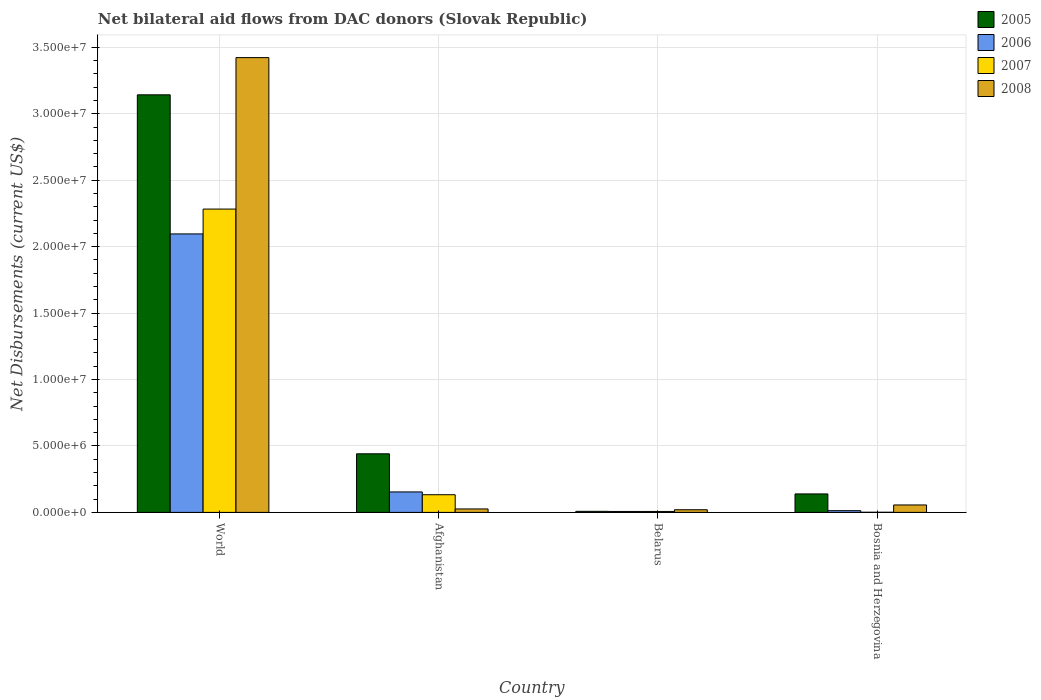How many different coloured bars are there?
Make the answer very short. 4. Are the number of bars per tick equal to the number of legend labels?
Give a very brief answer. Yes. How many bars are there on the 2nd tick from the left?
Your answer should be compact. 4. How many bars are there on the 4th tick from the right?
Your answer should be compact. 4. What is the label of the 3rd group of bars from the left?
Provide a short and direct response. Belarus. What is the net bilateral aid flows in 2008 in World?
Offer a terse response. 3.42e+07. Across all countries, what is the maximum net bilateral aid flows in 2007?
Your response must be concise. 2.28e+07. Across all countries, what is the minimum net bilateral aid flows in 2006?
Offer a terse response. 7.00e+04. In which country was the net bilateral aid flows in 2008 minimum?
Your answer should be compact. Belarus. What is the total net bilateral aid flows in 2008 in the graph?
Provide a succinct answer. 3.52e+07. What is the difference between the net bilateral aid flows in 2006 in Afghanistan and that in World?
Offer a very short reply. -1.94e+07. What is the difference between the net bilateral aid flows in 2008 in Bosnia and Herzegovina and the net bilateral aid flows in 2005 in World?
Ensure brevity in your answer.  -3.09e+07. What is the average net bilateral aid flows in 2006 per country?
Provide a short and direct response. 5.68e+06. What is the difference between the net bilateral aid flows of/in 2007 and net bilateral aid flows of/in 2008 in Bosnia and Herzegovina?
Offer a terse response. -5.50e+05. Is the difference between the net bilateral aid flows in 2007 in Afghanistan and World greater than the difference between the net bilateral aid flows in 2008 in Afghanistan and World?
Ensure brevity in your answer.  Yes. What is the difference between the highest and the second highest net bilateral aid flows in 2005?
Ensure brevity in your answer.  2.70e+07. What is the difference between the highest and the lowest net bilateral aid flows in 2007?
Your response must be concise. 2.28e+07. What does the 3rd bar from the left in World represents?
Give a very brief answer. 2007. Is it the case that in every country, the sum of the net bilateral aid flows in 2006 and net bilateral aid flows in 2008 is greater than the net bilateral aid flows in 2007?
Give a very brief answer. Yes. How many bars are there?
Provide a succinct answer. 16. What is the difference between two consecutive major ticks on the Y-axis?
Keep it short and to the point. 5.00e+06. How are the legend labels stacked?
Give a very brief answer. Vertical. What is the title of the graph?
Give a very brief answer. Net bilateral aid flows from DAC donors (Slovak Republic). What is the label or title of the X-axis?
Ensure brevity in your answer.  Country. What is the label or title of the Y-axis?
Keep it short and to the point. Net Disbursements (current US$). What is the Net Disbursements (current US$) in 2005 in World?
Keep it short and to the point. 3.14e+07. What is the Net Disbursements (current US$) in 2006 in World?
Offer a terse response. 2.10e+07. What is the Net Disbursements (current US$) of 2007 in World?
Your response must be concise. 2.28e+07. What is the Net Disbursements (current US$) of 2008 in World?
Provide a short and direct response. 3.42e+07. What is the Net Disbursements (current US$) of 2005 in Afghanistan?
Keep it short and to the point. 4.41e+06. What is the Net Disbursements (current US$) in 2006 in Afghanistan?
Provide a succinct answer. 1.54e+06. What is the Net Disbursements (current US$) in 2007 in Afghanistan?
Your answer should be very brief. 1.33e+06. What is the Net Disbursements (current US$) in 2008 in Afghanistan?
Your response must be concise. 2.60e+05. What is the Net Disbursements (current US$) in 2006 in Belarus?
Keep it short and to the point. 7.00e+04. What is the Net Disbursements (current US$) in 2007 in Belarus?
Give a very brief answer. 7.00e+04. What is the Net Disbursements (current US$) in 2005 in Bosnia and Herzegovina?
Offer a terse response. 1.39e+06. What is the Net Disbursements (current US$) of 2006 in Bosnia and Herzegovina?
Make the answer very short. 1.30e+05. What is the Net Disbursements (current US$) in 2007 in Bosnia and Herzegovina?
Your answer should be very brief. 10000. What is the Net Disbursements (current US$) in 2008 in Bosnia and Herzegovina?
Provide a short and direct response. 5.60e+05. Across all countries, what is the maximum Net Disbursements (current US$) of 2005?
Your answer should be very brief. 3.14e+07. Across all countries, what is the maximum Net Disbursements (current US$) in 2006?
Your answer should be compact. 2.10e+07. Across all countries, what is the maximum Net Disbursements (current US$) of 2007?
Make the answer very short. 2.28e+07. Across all countries, what is the maximum Net Disbursements (current US$) of 2008?
Provide a succinct answer. 3.42e+07. Across all countries, what is the minimum Net Disbursements (current US$) in 2007?
Offer a very short reply. 10000. What is the total Net Disbursements (current US$) of 2005 in the graph?
Give a very brief answer. 3.73e+07. What is the total Net Disbursements (current US$) of 2006 in the graph?
Give a very brief answer. 2.27e+07. What is the total Net Disbursements (current US$) of 2007 in the graph?
Provide a succinct answer. 2.42e+07. What is the total Net Disbursements (current US$) of 2008 in the graph?
Offer a very short reply. 3.52e+07. What is the difference between the Net Disbursements (current US$) of 2005 in World and that in Afghanistan?
Provide a succinct answer. 2.70e+07. What is the difference between the Net Disbursements (current US$) of 2006 in World and that in Afghanistan?
Your answer should be very brief. 1.94e+07. What is the difference between the Net Disbursements (current US$) in 2007 in World and that in Afghanistan?
Your answer should be very brief. 2.15e+07. What is the difference between the Net Disbursements (current US$) in 2008 in World and that in Afghanistan?
Ensure brevity in your answer.  3.40e+07. What is the difference between the Net Disbursements (current US$) in 2005 in World and that in Belarus?
Ensure brevity in your answer.  3.14e+07. What is the difference between the Net Disbursements (current US$) in 2006 in World and that in Belarus?
Offer a very short reply. 2.09e+07. What is the difference between the Net Disbursements (current US$) of 2007 in World and that in Belarus?
Offer a very short reply. 2.28e+07. What is the difference between the Net Disbursements (current US$) in 2008 in World and that in Belarus?
Make the answer very short. 3.40e+07. What is the difference between the Net Disbursements (current US$) in 2005 in World and that in Bosnia and Herzegovina?
Your response must be concise. 3.00e+07. What is the difference between the Net Disbursements (current US$) of 2006 in World and that in Bosnia and Herzegovina?
Your answer should be compact. 2.08e+07. What is the difference between the Net Disbursements (current US$) of 2007 in World and that in Bosnia and Herzegovina?
Make the answer very short. 2.28e+07. What is the difference between the Net Disbursements (current US$) of 2008 in World and that in Bosnia and Herzegovina?
Your answer should be very brief. 3.37e+07. What is the difference between the Net Disbursements (current US$) of 2005 in Afghanistan and that in Belarus?
Give a very brief answer. 4.33e+06. What is the difference between the Net Disbursements (current US$) of 2006 in Afghanistan and that in Belarus?
Your response must be concise. 1.47e+06. What is the difference between the Net Disbursements (current US$) of 2007 in Afghanistan and that in Belarus?
Your answer should be very brief. 1.26e+06. What is the difference between the Net Disbursements (current US$) of 2008 in Afghanistan and that in Belarus?
Your answer should be very brief. 6.00e+04. What is the difference between the Net Disbursements (current US$) of 2005 in Afghanistan and that in Bosnia and Herzegovina?
Give a very brief answer. 3.02e+06. What is the difference between the Net Disbursements (current US$) of 2006 in Afghanistan and that in Bosnia and Herzegovina?
Offer a terse response. 1.41e+06. What is the difference between the Net Disbursements (current US$) in 2007 in Afghanistan and that in Bosnia and Herzegovina?
Provide a succinct answer. 1.32e+06. What is the difference between the Net Disbursements (current US$) of 2008 in Afghanistan and that in Bosnia and Herzegovina?
Offer a very short reply. -3.00e+05. What is the difference between the Net Disbursements (current US$) in 2005 in Belarus and that in Bosnia and Herzegovina?
Your response must be concise. -1.31e+06. What is the difference between the Net Disbursements (current US$) of 2006 in Belarus and that in Bosnia and Herzegovina?
Offer a terse response. -6.00e+04. What is the difference between the Net Disbursements (current US$) of 2008 in Belarus and that in Bosnia and Herzegovina?
Your response must be concise. -3.60e+05. What is the difference between the Net Disbursements (current US$) of 2005 in World and the Net Disbursements (current US$) of 2006 in Afghanistan?
Give a very brief answer. 2.99e+07. What is the difference between the Net Disbursements (current US$) in 2005 in World and the Net Disbursements (current US$) in 2007 in Afghanistan?
Ensure brevity in your answer.  3.01e+07. What is the difference between the Net Disbursements (current US$) of 2005 in World and the Net Disbursements (current US$) of 2008 in Afghanistan?
Ensure brevity in your answer.  3.12e+07. What is the difference between the Net Disbursements (current US$) of 2006 in World and the Net Disbursements (current US$) of 2007 in Afghanistan?
Give a very brief answer. 1.96e+07. What is the difference between the Net Disbursements (current US$) in 2006 in World and the Net Disbursements (current US$) in 2008 in Afghanistan?
Provide a succinct answer. 2.07e+07. What is the difference between the Net Disbursements (current US$) of 2007 in World and the Net Disbursements (current US$) of 2008 in Afghanistan?
Your answer should be compact. 2.26e+07. What is the difference between the Net Disbursements (current US$) of 2005 in World and the Net Disbursements (current US$) of 2006 in Belarus?
Your answer should be compact. 3.14e+07. What is the difference between the Net Disbursements (current US$) in 2005 in World and the Net Disbursements (current US$) in 2007 in Belarus?
Provide a short and direct response. 3.14e+07. What is the difference between the Net Disbursements (current US$) in 2005 in World and the Net Disbursements (current US$) in 2008 in Belarus?
Ensure brevity in your answer.  3.12e+07. What is the difference between the Net Disbursements (current US$) of 2006 in World and the Net Disbursements (current US$) of 2007 in Belarus?
Your answer should be compact. 2.09e+07. What is the difference between the Net Disbursements (current US$) in 2006 in World and the Net Disbursements (current US$) in 2008 in Belarus?
Your response must be concise. 2.08e+07. What is the difference between the Net Disbursements (current US$) of 2007 in World and the Net Disbursements (current US$) of 2008 in Belarus?
Offer a very short reply. 2.26e+07. What is the difference between the Net Disbursements (current US$) in 2005 in World and the Net Disbursements (current US$) in 2006 in Bosnia and Herzegovina?
Give a very brief answer. 3.13e+07. What is the difference between the Net Disbursements (current US$) of 2005 in World and the Net Disbursements (current US$) of 2007 in Bosnia and Herzegovina?
Ensure brevity in your answer.  3.14e+07. What is the difference between the Net Disbursements (current US$) of 2005 in World and the Net Disbursements (current US$) of 2008 in Bosnia and Herzegovina?
Offer a very short reply. 3.09e+07. What is the difference between the Net Disbursements (current US$) of 2006 in World and the Net Disbursements (current US$) of 2007 in Bosnia and Herzegovina?
Provide a short and direct response. 2.10e+07. What is the difference between the Net Disbursements (current US$) of 2006 in World and the Net Disbursements (current US$) of 2008 in Bosnia and Herzegovina?
Provide a short and direct response. 2.04e+07. What is the difference between the Net Disbursements (current US$) in 2007 in World and the Net Disbursements (current US$) in 2008 in Bosnia and Herzegovina?
Give a very brief answer. 2.23e+07. What is the difference between the Net Disbursements (current US$) in 2005 in Afghanistan and the Net Disbursements (current US$) in 2006 in Belarus?
Provide a succinct answer. 4.34e+06. What is the difference between the Net Disbursements (current US$) of 2005 in Afghanistan and the Net Disbursements (current US$) of 2007 in Belarus?
Provide a succinct answer. 4.34e+06. What is the difference between the Net Disbursements (current US$) of 2005 in Afghanistan and the Net Disbursements (current US$) of 2008 in Belarus?
Offer a terse response. 4.21e+06. What is the difference between the Net Disbursements (current US$) in 2006 in Afghanistan and the Net Disbursements (current US$) in 2007 in Belarus?
Provide a succinct answer. 1.47e+06. What is the difference between the Net Disbursements (current US$) of 2006 in Afghanistan and the Net Disbursements (current US$) of 2008 in Belarus?
Ensure brevity in your answer.  1.34e+06. What is the difference between the Net Disbursements (current US$) of 2007 in Afghanistan and the Net Disbursements (current US$) of 2008 in Belarus?
Offer a very short reply. 1.13e+06. What is the difference between the Net Disbursements (current US$) of 2005 in Afghanistan and the Net Disbursements (current US$) of 2006 in Bosnia and Herzegovina?
Your answer should be compact. 4.28e+06. What is the difference between the Net Disbursements (current US$) of 2005 in Afghanistan and the Net Disbursements (current US$) of 2007 in Bosnia and Herzegovina?
Offer a terse response. 4.40e+06. What is the difference between the Net Disbursements (current US$) of 2005 in Afghanistan and the Net Disbursements (current US$) of 2008 in Bosnia and Herzegovina?
Make the answer very short. 3.85e+06. What is the difference between the Net Disbursements (current US$) of 2006 in Afghanistan and the Net Disbursements (current US$) of 2007 in Bosnia and Herzegovina?
Your response must be concise. 1.53e+06. What is the difference between the Net Disbursements (current US$) in 2006 in Afghanistan and the Net Disbursements (current US$) in 2008 in Bosnia and Herzegovina?
Offer a terse response. 9.80e+05. What is the difference between the Net Disbursements (current US$) in 2007 in Afghanistan and the Net Disbursements (current US$) in 2008 in Bosnia and Herzegovina?
Ensure brevity in your answer.  7.70e+05. What is the difference between the Net Disbursements (current US$) of 2005 in Belarus and the Net Disbursements (current US$) of 2007 in Bosnia and Herzegovina?
Your answer should be very brief. 7.00e+04. What is the difference between the Net Disbursements (current US$) of 2005 in Belarus and the Net Disbursements (current US$) of 2008 in Bosnia and Herzegovina?
Provide a succinct answer. -4.80e+05. What is the difference between the Net Disbursements (current US$) of 2006 in Belarus and the Net Disbursements (current US$) of 2008 in Bosnia and Herzegovina?
Ensure brevity in your answer.  -4.90e+05. What is the difference between the Net Disbursements (current US$) in 2007 in Belarus and the Net Disbursements (current US$) in 2008 in Bosnia and Herzegovina?
Keep it short and to the point. -4.90e+05. What is the average Net Disbursements (current US$) of 2005 per country?
Provide a succinct answer. 9.33e+06. What is the average Net Disbursements (current US$) in 2006 per country?
Give a very brief answer. 5.68e+06. What is the average Net Disbursements (current US$) in 2007 per country?
Ensure brevity in your answer.  6.06e+06. What is the average Net Disbursements (current US$) of 2008 per country?
Offer a terse response. 8.81e+06. What is the difference between the Net Disbursements (current US$) of 2005 and Net Disbursements (current US$) of 2006 in World?
Provide a succinct answer. 1.05e+07. What is the difference between the Net Disbursements (current US$) in 2005 and Net Disbursements (current US$) in 2007 in World?
Make the answer very short. 8.60e+06. What is the difference between the Net Disbursements (current US$) of 2005 and Net Disbursements (current US$) of 2008 in World?
Your answer should be compact. -2.80e+06. What is the difference between the Net Disbursements (current US$) in 2006 and Net Disbursements (current US$) in 2007 in World?
Offer a very short reply. -1.87e+06. What is the difference between the Net Disbursements (current US$) of 2006 and Net Disbursements (current US$) of 2008 in World?
Ensure brevity in your answer.  -1.33e+07. What is the difference between the Net Disbursements (current US$) of 2007 and Net Disbursements (current US$) of 2008 in World?
Your answer should be very brief. -1.14e+07. What is the difference between the Net Disbursements (current US$) in 2005 and Net Disbursements (current US$) in 2006 in Afghanistan?
Provide a short and direct response. 2.87e+06. What is the difference between the Net Disbursements (current US$) in 2005 and Net Disbursements (current US$) in 2007 in Afghanistan?
Keep it short and to the point. 3.08e+06. What is the difference between the Net Disbursements (current US$) in 2005 and Net Disbursements (current US$) in 2008 in Afghanistan?
Your answer should be very brief. 4.15e+06. What is the difference between the Net Disbursements (current US$) of 2006 and Net Disbursements (current US$) of 2007 in Afghanistan?
Offer a very short reply. 2.10e+05. What is the difference between the Net Disbursements (current US$) in 2006 and Net Disbursements (current US$) in 2008 in Afghanistan?
Offer a very short reply. 1.28e+06. What is the difference between the Net Disbursements (current US$) in 2007 and Net Disbursements (current US$) in 2008 in Afghanistan?
Make the answer very short. 1.07e+06. What is the difference between the Net Disbursements (current US$) of 2005 and Net Disbursements (current US$) of 2007 in Belarus?
Your response must be concise. 10000. What is the difference between the Net Disbursements (current US$) of 2006 and Net Disbursements (current US$) of 2007 in Belarus?
Provide a short and direct response. 0. What is the difference between the Net Disbursements (current US$) in 2006 and Net Disbursements (current US$) in 2008 in Belarus?
Provide a succinct answer. -1.30e+05. What is the difference between the Net Disbursements (current US$) in 2005 and Net Disbursements (current US$) in 2006 in Bosnia and Herzegovina?
Offer a very short reply. 1.26e+06. What is the difference between the Net Disbursements (current US$) of 2005 and Net Disbursements (current US$) of 2007 in Bosnia and Herzegovina?
Your answer should be very brief. 1.38e+06. What is the difference between the Net Disbursements (current US$) of 2005 and Net Disbursements (current US$) of 2008 in Bosnia and Herzegovina?
Ensure brevity in your answer.  8.30e+05. What is the difference between the Net Disbursements (current US$) in 2006 and Net Disbursements (current US$) in 2007 in Bosnia and Herzegovina?
Make the answer very short. 1.20e+05. What is the difference between the Net Disbursements (current US$) in 2006 and Net Disbursements (current US$) in 2008 in Bosnia and Herzegovina?
Your answer should be very brief. -4.30e+05. What is the difference between the Net Disbursements (current US$) in 2007 and Net Disbursements (current US$) in 2008 in Bosnia and Herzegovina?
Provide a short and direct response. -5.50e+05. What is the ratio of the Net Disbursements (current US$) in 2005 in World to that in Afghanistan?
Offer a terse response. 7.13. What is the ratio of the Net Disbursements (current US$) of 2006 in World to that in Afghanistan?
Your response must be concise. 13.61. What is the ratio of the Net Disbursements (current US$) of 2007 in World to that in Afghanistan?
Offer a terse response. 17.17. What is the ratio of the Net Disbursements (current US$) in 2008 in World to that in Afghanistan?
Your answer should be compact. 131.65. What is the ratio of the Net Disbursements (current US$) of 2005 in World to that in Belarus?
Your response must be concise. 392.88. What is the ratio of the Net Disbursements (current US$) in 2006 in World to that in Belarus?
Offer a terse response. 299.43. What is the ratio of the Net Disbursements (current US$) in 2007 in World to that in Belarus?
Offer a very short reply. 326.14. What is the ratio of the Net Disbursements (current US$) of 2008 in World to that in Belarus?
Keep it short and to the point. 171.15. What is the ratio of the Net Disbursements (current US$) of 2005 in World to that in Bosnia and Herzegovina?
Your response must be concise. 22.61. What is the ratio of the Net Disbursements (current US$) in 2006 in World to that in Bosnia and Herzegovina?
Your answer should be very brief. 161.23. What is the ratio of the Net Disbursements (current US$) of 2007 in World to that in Bosnia and Herzegovina?
Provide a short and direct response. 2283. What is the ratio of the Net Disbursements (current US$) of 2008 in World to that in Bosnia and Herzegovina?
Offer a very short reply. 61.12. What is the ratio of the Net Disbursements (current US$) of 2005 in Afghanistan to that in Belarus?
Offer a very short reply. 55.12. What is the ratio of the Net Disbursements (current US$) in 2006 in Afghanistan to that in Belarus?
Keep it short and to the point. 22. What is the ratio of the Net Disbursements (current US$) in 2007 in Afghanistan to that in Belarus?
Ensure brevity in your answer.  19. What is the ratio of the Net Disbursements (current US$) in 2008 in Afghanistan to that in Belarus?
Make the answer very short. 1.3. What is the ratio of the Net Disbursements (current US$) of 2005 in Afghanistan to that in Bosnia and Herzegovina?
Your answer should be compact. 3.17. What is the ratio of the Net Disbursements (current US$) in 2006 in Afghanistan to that in Bosnia and Herzegovina?
Provide a short and direct response. 11.85. What is the ratio of the Net Disbursements (current US$) of 2007 in Afghanistan to that in Bosnia and Herzegovina?
Your answer should be very brief. 133. What is the ratio of the Net Disbursements (current US$) of 2008 in Afghanistan to that in Bosnia and Herzegovina?
Your answer should be compact. 0.46. What is the ratio of the Net Disbursements (current US$) of 2005 in Belarus to that in Bosnia and Herzegovina?
Ensure brevity in your answer.  0.06. What is the ratio of the Net Disbursements (current US$) in 2006 in Belarus to that in Bosnia and Herzegovina?
Your answer should be compact. 0.54. What is the ratio of the Net Disbursements (current US$) in 2008 in Belarus to that in Bosnia and Herzegovina?
Make the answer very short. 0.36. What is the difference between the highest and the second highest Net Disbursements (current US$) in 2005?
Provide a succinct answer. 2.70e+07. What is the difference between the highest and the second highest Net Disbursements (current US$) in 2006?
Your answer should be compact. 1.94e+07. What is the difference between the highest and the second highest Net Disbursements (current US$) in 2007?
Ensure brevity in your answer.  2.15e+07. What is the difference between the highest and the second highest Net Disbursements (current US$) of 2008?
Your response must be concise. 3.37e+07. What is the difference between the highest and the lowest Net Disbursements (current US$) of 2005?
Give a very brief answer. 3.14e+07. What is the difference between the highest and the lowest Net Disbursements (current US$) in 2006?
Ensure brevity in your answer.  2.09e+07. What is the difference between the highest and the lowest Net Disbursements (current US$) of 2007?
Keep it short and to the point. 2.28e+07. What is the difference between the highest and the lowest Net Disbursements (current US$) in 2008?
Ensure brevity in your answer.  3.40e+07. 